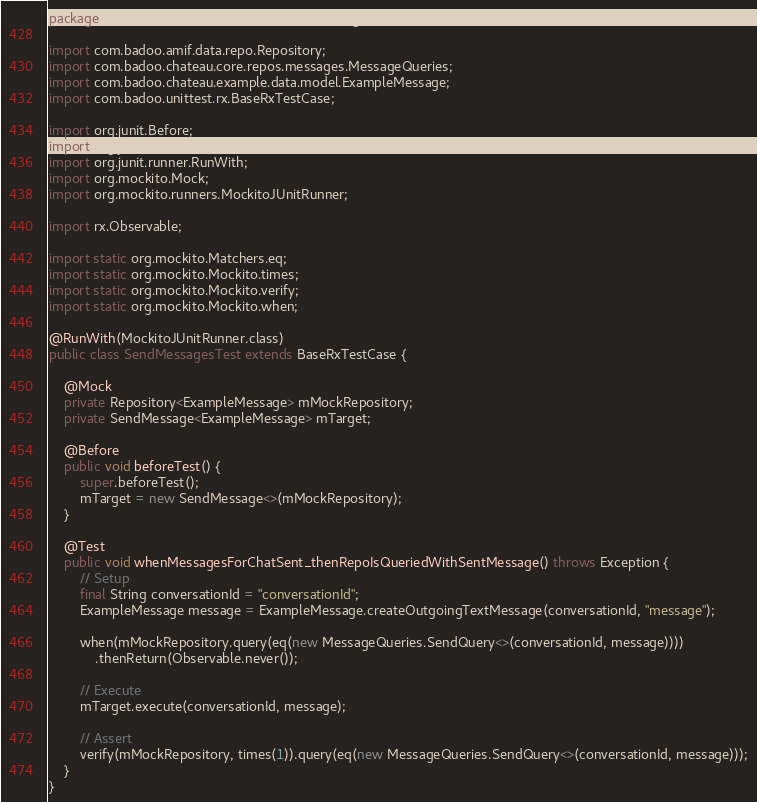Convert code to text. <code><loc_0><loc_0><loc_500><loc_500><_Java_>package com.badoo.chateau.core.usecases.messages;

import com.badoo.amif.data.repo.Repository;
import com.badoo.chateau.core.repos.messages.MessageQueries;
import com.badoo.chateau.example.data.model.ExampleMessage;
import com.badoo.unittest.rx.BaseRxTestCase;

import org.junit.Before;
import org.junit.Test;
import org.junit.runner.RunWith;
import org.mockito.Mock;
import org.mockito.runners.MockitoJUnitRunner;

import rx.Observable;

import static org.mockito.Matchers.eq;
import static org.mockito.Mockito.times;
import static org.mockito.Mockito.verify;
import static org.mockito.Mockito.when;

@RunWith(MockitoJUnitRunner.class)
public class SendMessagesTest extends BaseRxTestCase {

    @Mock
    private Repository<ExampleMessage> mMockRepository;
    private SendMessage<ExampleMessage> mTarget;

    @Before
    public void beforeTest() {
        super.beforeTest();
        mTarget = new SendMessage<>(mMockRepository);
    }

    @Test
    public void whenMessagesForChatSent_thenRepoIsQueriedWithSentMessage() throws Exception {
        // Setup
        final String conversationId = "conversationId";
        ExampleMessage message = ExampleMessage.createOutgoingTextMessage(conversationId, "message");

        when(mMockRepository.query(eq(new MessageQueries.SendQuery<>(conversationId, message))))
            .thenReturn(Observable.never());

        // Execute
        mTarget.execute(conversationId, message);

        // Assert
        verify(mMockRepository, times(1)).query(eq(new MessageQueries.SendQuery<>(conversationId, message)));
    }
}</code> 